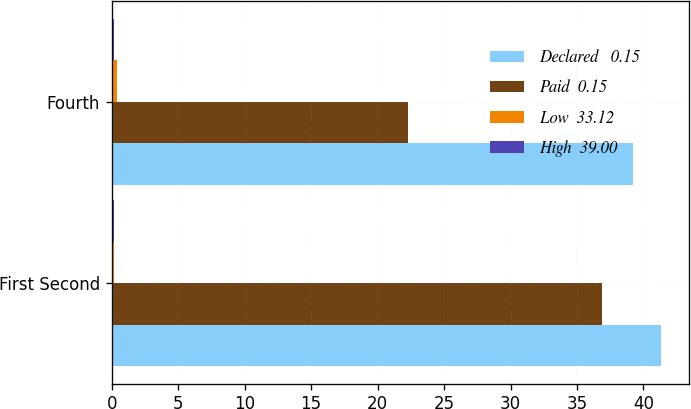Convert chart. <chart><loc_0><loc_0><loc_500><loc_500><stacked_bar_chart><ecel><fcel>First Second<fcel>Fourth<nl><fcel>Declared   0.15<fcel>41.34<fcel>39.23<nl><fcel>Paid  0.15<fcel>36.85<fcel>22.25<nl><fcel>Low  33.12<fcel>0.19<fcel>0.38<nl><fcel>High  39.00<fcel>0.15<fcel>0.19<nl></chart> 